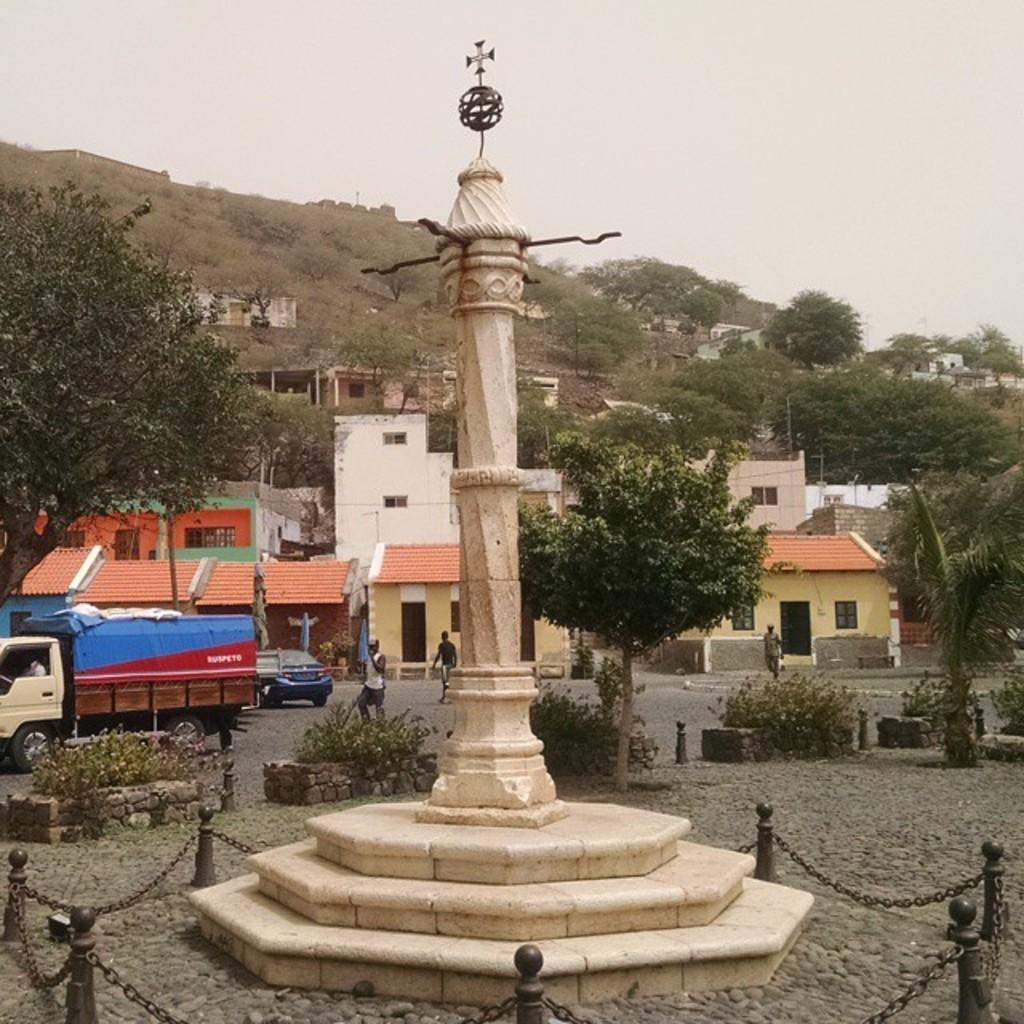Could you give a brief overview of what you see in this image? In this picture there is a tower in the center of the image and their vehicles on the left side of the image, there are buildings and trees in the background area of the image. 